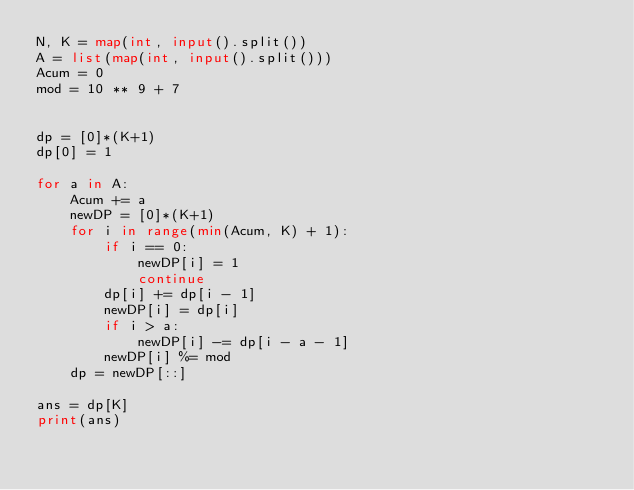<code> <loc_0><loc_0><loc_500><loc_500><_Python_>N, K = map(int, input().split())
A = list(map(int, input().split()))
Acum = 0
mod = 10 ** 9 + 7


dp = [0]*(K+1)
dp[0] = 1

for a in A:
    Acum += a
    newDP = [0]*(K+1)
    for i in range(min(Acum, K) + 1):
        if i == 0:
            newDP[i] = 1
            continue
        dp[i] += dp[i - 1]
        newDP[i] = dp[i]
        if i > a:
            newDP[i] -= dp[i - a - 1]
        newDP[i] %= mod
    dp = newDP[::]

ans = dp[K]
print(ans)
</code> 